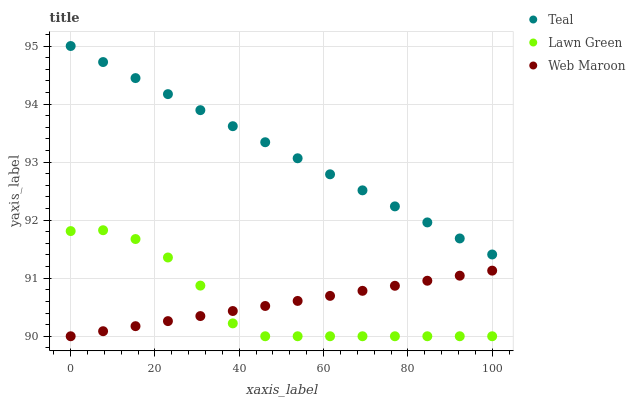Does Lawn Green have the minimum area under the curve?
Answer yes or no. Yes. Does Teal have the maximum area under the curve?
Answer yes or no. Yes. Does Web Maroon have the minimum area under the curve?
Answer yes or no. No. Does Web Maroon have the maximum area under the curve?
Answer yes or no. No. Is Web Maroon the smoothest?
Answer yes or no. Yes. Is Lawn Green the roughest?
Answer yes or no. Yes. Is Teal the smoothest?
Answer yes or no. No. Is Teal the roughest?
Answer yes or no. No. Does Lawn Green have the lowest value?
Answer yes or no. Yes. Does Teal have the lowest value?
Answer yes or no. No. Does Teal have the highest value?
Answer yes or no. Yes. Does Web Maroon have the highest value?
Answer yes or no. No. Is Lawn Green less than Teal?
Answer yes or no. Yes. Is Teal greater than Web Maroon?
Answer yes or no. Yes. Does Lawn Green intersect Web Maroon?
Answer yes or no. Yes. Is Lawn Green less than Web Maroon?
Answer yes or no. No. Is Lawn Green greater than Web Maroon?
Answer yes or no. No. Does Lawn Green intersect Teal?
Answer yes or no. No. 